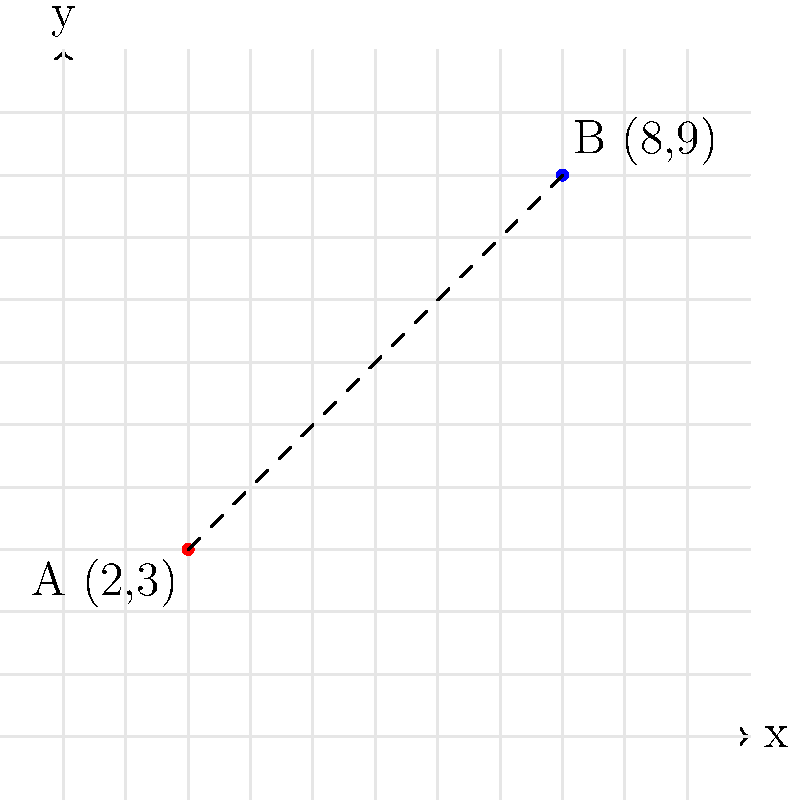On the tactical map, two enemy positions A and B are marked with their respective Cartesian coordinates. Position A is at (2,3) and position B is at (8,9). What is the straight-line distance between these two positions? Round your answer to two decimal places. To find the straight-line distance between two points on a Cartesian plane, we can use the distance formula, which is derived from the Pythagorean theorem:

$$ d = \sqrt{(x_2-x_1)^2 + (y_2-y_1)^2} $$

Where $(x_1,y_1)$ are the coordinates of the first point and $(x_2,y_2)$ are the coordinates of the second point.

Given:
- Point A: $(x_1,y_1) = (2,3)$
- Point B: $(x_2,y_2) = (8,9)$

Let's plug these values into the formula:

$$ d = \sqrt{(8-2)^2 + (9-3)^2} $$

Simplify:
$$ d = \sqrt{6^2 + 6^2} $$
$$ d = \sqrt{36 + 36} $$
$$ d = \sqrt{72} $$

Simplify the square root:
$$ d = 6\sqrt{2} $$

Calculate the decimal approximation:
$$ d \approx 8.4853 $$

Rounding to two decimal places:
$$ d \approx 8.49 $$

Therefore, the straight-line distance between the two enemy positions is approximately 8.49 units on the tactical map.
Answer: 8.49 units 